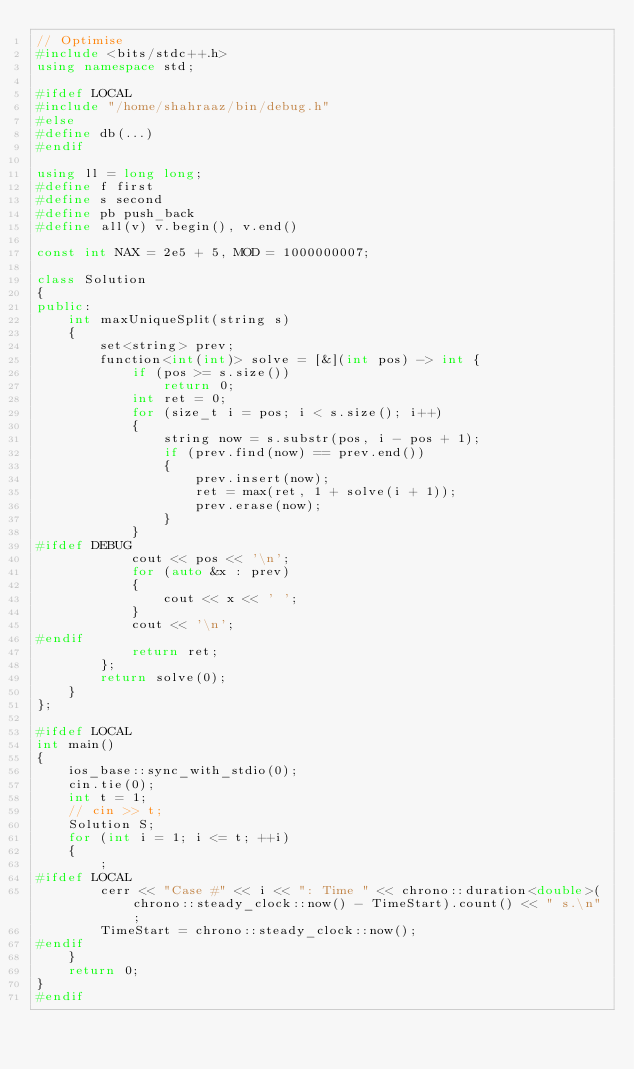<code> <loc_0><loc_0><loc_500><loc_500><_C++_>// Optimise
#include <bits/stdc++.h>
using namespace std;

#ifdef LOCAL
#include "/home/shahraaz/bin/debug.h"
#else
#define db(...)
#endif

using ll = long long;
#define f first
#define s second
#define pb push_back
#define all(v) v.begin(), v.end()

const int NAX = 2e5 + 5, MOD = 1000000007;

class Solution
{
public:
    int maxUniqueSplit(string s)
    {
        set<string> prev;
        function<int(int)> solve = [&](int pos) -> int {
            if (pos >= s.size())
                return 0;
            int ret = 0;
            for (size_t i = pos; i < s.size(); i++)
            {
                string now = s.substr(pos, i - pos + 1);
                if (prev.find(now) == prev.end())
                {
                    prev.insert(now);
                    ret = max(ret, 1 + solve(i + 1));
                    prev.erase(now);
                }
            }
#ifdef DEBUG
            cout << pos << '\n';
            for (auto &x : prev)
            {
                cout << x << ' ';
            }
            cout << '\n';
#endif
            return ret;
        };
        return solve(0);
    }
};

#ifdef LOCAL
int main()
{
    ios_base::sync_with_stdio(0);
    cin.tie(0);
    int t = 1;
    // cin >> t;
    Solution S;
    for (int i = 1; i <= t; ++i)
    {
        ;
#ifdef LOCAL
        cerr << "Case #" << i << ": Time " << chrono::duration<double>(chrono::steady_clock::now() - TimeStart).count() << " s.\n";
        TimeStart = chrono::steady_clock::now();
#endif
    }
    return 0;
}
#endif</code> 